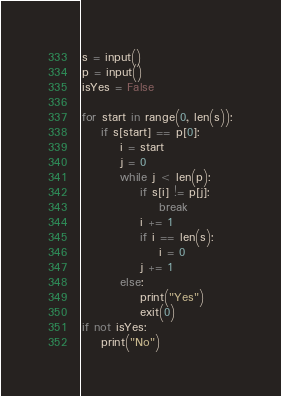Convert code to text. <code><loc_0><loc_0><loc_500><loc_500><_Python_>s = input()
p = input()
isYes = False

for start in range(0, len(s)):
    if s[start] == p[0]:
        i = start
        j = 0
        while j < len(p):
            if s[i] != p[j]:
                break
            i += 1
            if i == len(s):
                i = 0
            j += 1
        else:
            print("Yes")
            exit(0)
if not isYes:
    print("No")

</code> 